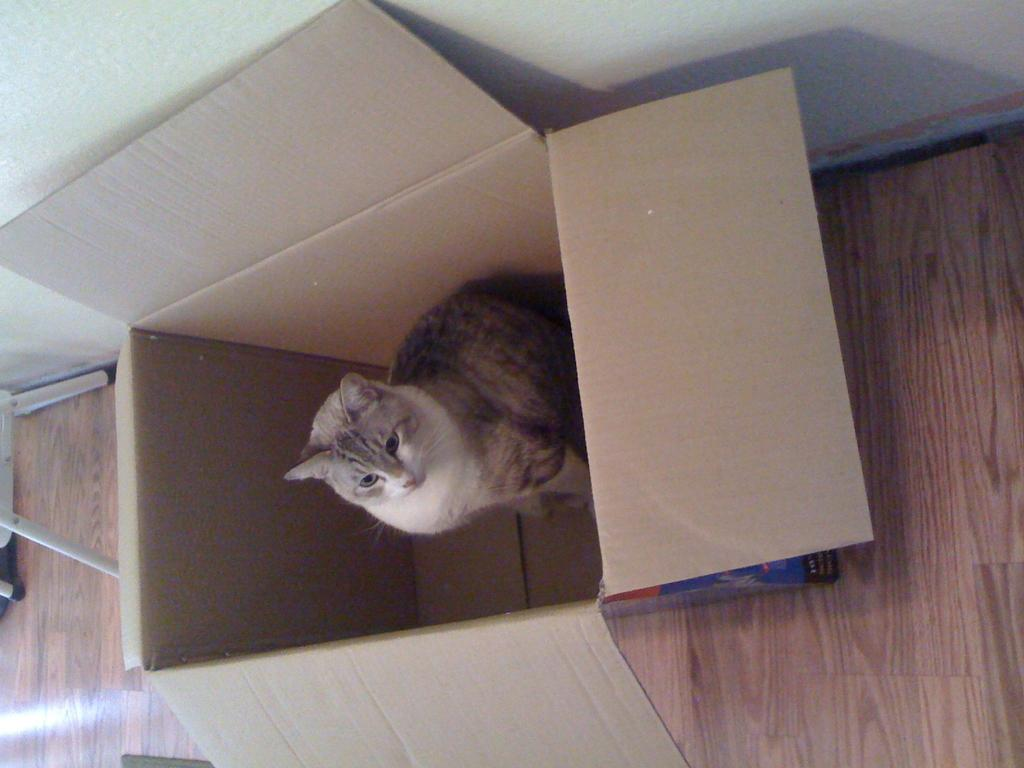What animal is present in the image? There is a cat in the image. Where is the cat located? The cat is in a box. Can you describe the position of the box in the image? The box is beside a wall. What type of class is the cat attending in the image? There is no indication of a class or any educational setting in the image; it simply features a cat in a box beside a wall. 